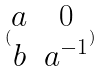Convert formula to latex. <formula><loc_0><loc_0><loc_500><loc_500>( \begin{matrix} a & 0 \\ b & a ^ { - 1 } \end{matrix} )</formula> 